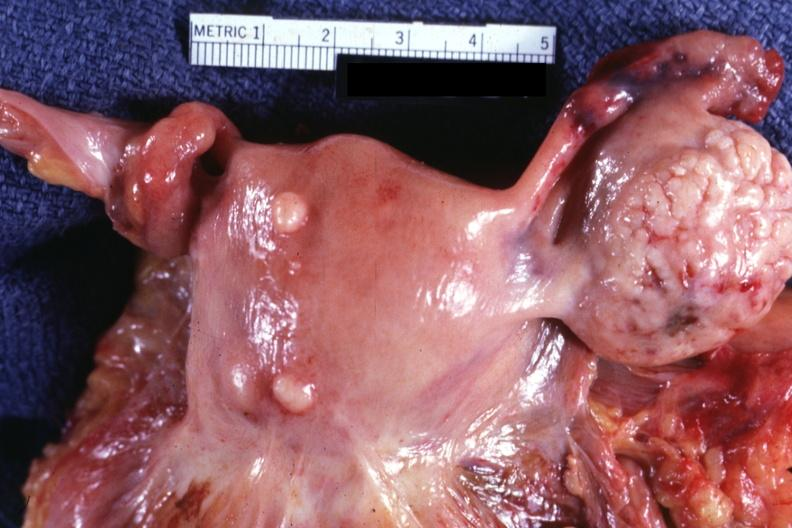do a bulge represent?
Answer the question using a single word or phrase. Yes 